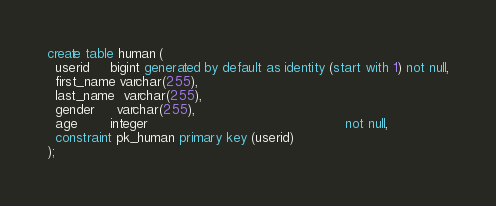<code> <loc_0><loc_0><loc_500><loc_500><_SQL_>create table human (
  userid     bigint generated by default as identity (start with 1) not null,
  first_name varchar(255),
  last_name  varchar(255),
  gender     varchar(255),
  age        integer                                                not null,
  constraint pk_human primary key (userid)
);

</code> 